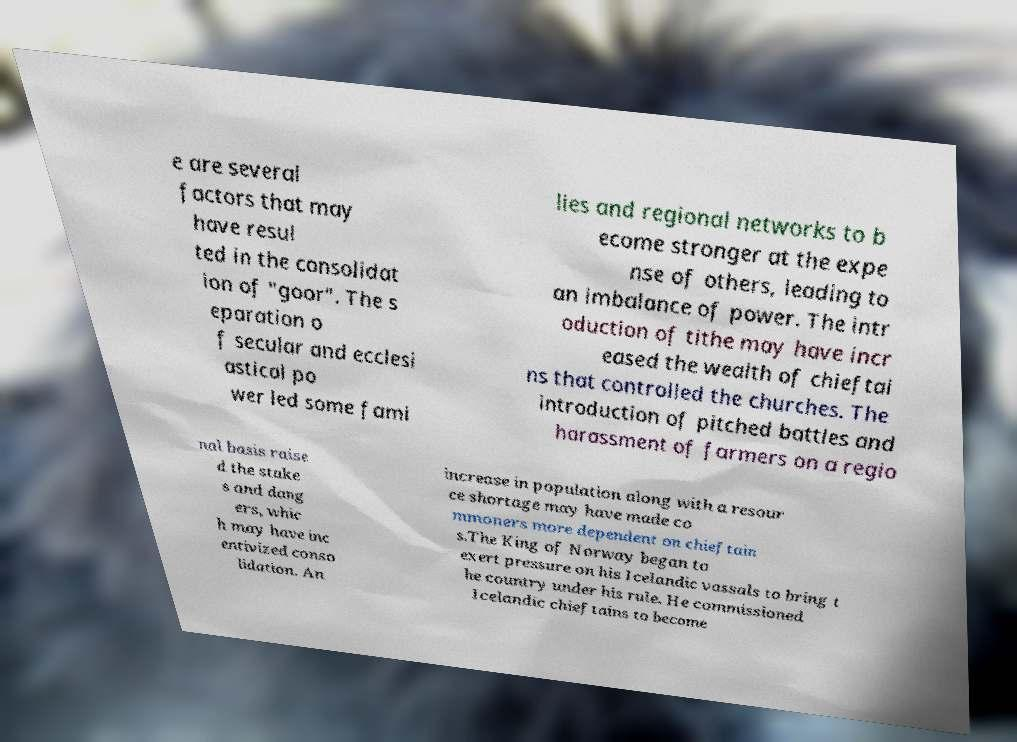What messages or text are displayed in this image? I need them in a readable, typed format. e are several factors that may have resul ted in the consolidat ion of "goor". The s eparation o f secular and ecclesi astical po wer led some fami lies and regional networks to b ecome stronger at the expe nse of others, leading to an imbalance of power. The intr oduction of tithe may have incr eased the wealth of chieftai ns that controlled the churches. The introduction of pitched battles and harassment of farmers on a regio nal basis raise d the stake s and dang ers, whic h may have inc entivized conso lidation. An increase in population along with a resour ce shortage may have made co mmoners more dependent on chieftain s.The King of Norway began to exert pressure on his Icelandic vassals to bring t he country under his rule. He commissioned Icelandic chieftains to become 